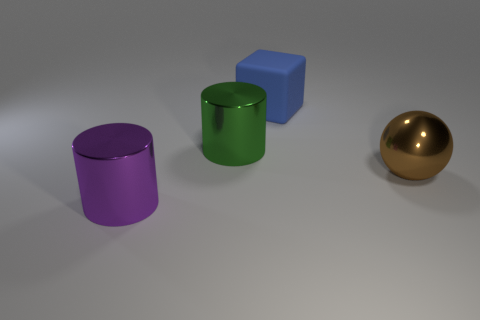Does the big green metal object have the same shape as the large object that is behind the big green cylinder?
Your answer should be very brief. No. There is a green metallic thing that is the same shape as the purple thing; what is its size?
Your response must be concise. Large. Is the color of the matte block the same as the cylinder right of the large purple metal thing?
Keep it short and to the point. No. How many other objects are the same size as the brown metal sphere?
Ensure brevity in your answer.  3. There is a shiny object right of the big metal cylinder that is right of the cylinder in front of the ball; what shape is it?
Provide a short and direct response. Sphere. Is the size of the green metallic cylinder the same as the cylinder in front of the large green thing?
Make the answer very short. Yes. There is a big object that is on the left side of the rubber cube and behind the big brown metal ball; what color is it?
Keep it short and to the point. Green. How many other things are there of the same shape as the blue object?
Give a very brief answer. 0. Do the big object left of the green metallic cylinder and the big metal cylinder that is to the right of the large purple shiny thing have the same color?
Keep it short and to the point. No. There is a thing right of the big rubber thing; is it the same size as the purple object that is left of the brown shiny object?
Your answer should be compact. Yes. 